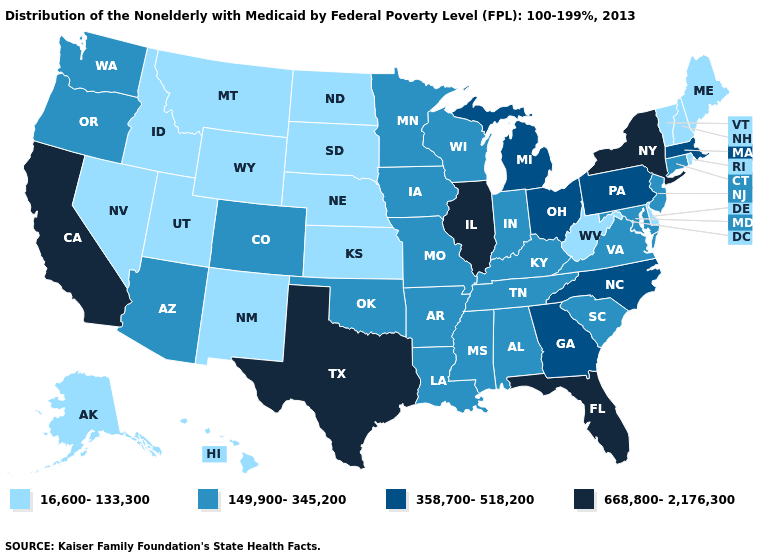Is the legend a continuous bar?
Be succinct. No. What is the value of New Hampshire?
Write a very short answer. 16,600-133,300. What is the value of Illinois?
Keep it brief. 668,800-2,176,300. Name the states that have a value in the range 358,700-518,200?
Short answer required. Georgia, Massachusetts, Michigan, North Carolina, Ohio, Pennsylvania. What is the value of New Jersey?
Quick response, please. 149,900-345,200. Name the states that have a value in the range 358,700-518,200?
Be succinct. Georgia, Massachusetts, Michigan, North Carolina, Ohio, Pennsylvania. What is the value of Pennsylvania?
Answer briefly. 358,700-518,200. Name the states that have a value in the range 358,700-518,200?
Give a very brief answer. Georgia, Massachusetts, Michigan, North Carolina, Ohio, Pennsylvania. Does Delaware have the highest value in the South?
Quick response, please. No. What is the lowest value in states that border Washington?
Keep it brief. 16,600-133,300. What is the lowest value in the USA?
Write a very short answer. 16,600-133,300. Does New York have the highest value in the USA?
Give a very brief answer. Yes. Among the states that border Wisconsin , which have the lowest value?
Quick response, please. Iowa, Minnesota. Name the states that have a value in the range 358,700-518,200?
Write a very short answer. Georgia, Massachusetts, Michigan, North Carolina, Ohio, Pennsylvania. Name the states that have a value in the range 358,700-518,200?
Write a very short answer. Georgia, Massachusetts, Michigan, North Carolina, Ohio, Pennsylvania. 